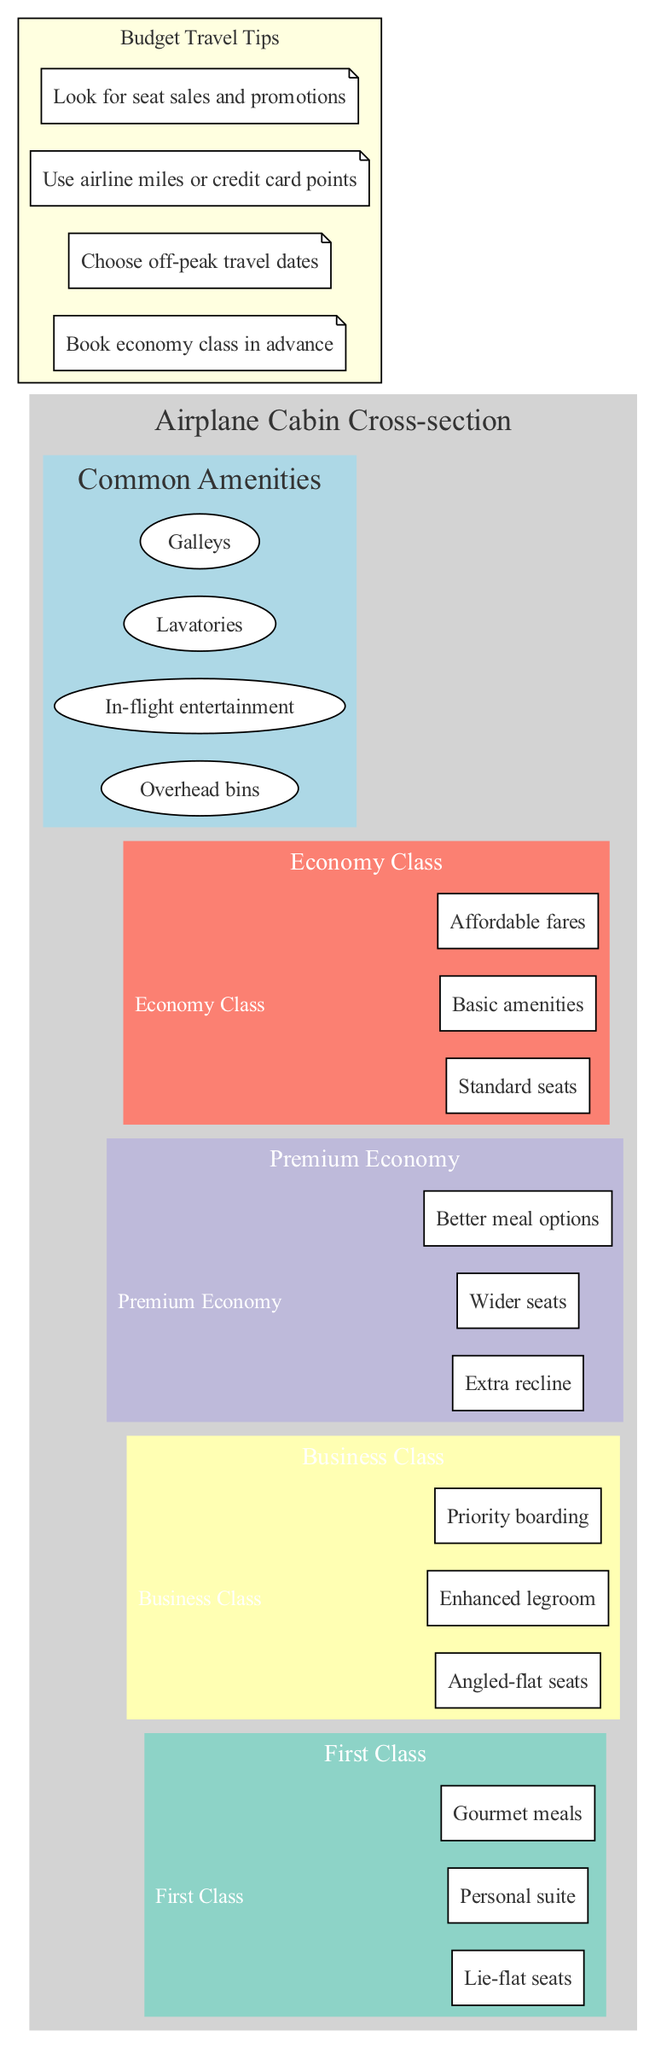What are the three main seating classes shown in the diagram? The diagram highlights four seating classes: First Class, Business Class, Premium Economy, and Economy Class. The question asks for three of these classes, which can be any three listed in the diagram. Common selections based on comfort and amenities would be First Class, Business Class, and Premium Economy.
Answer: First Class, Business Class, Premium Economy What is a feature unique to First Class? Under First Class in the diagram, one feature listed is "Personal suite." This feature distinctly represents the high level of comfort and privacy offered to First Class passengers compared to other classes.
Answer: Personal suite What type of seats are found in Business Class? The diagram specifies that Business Class has "Angled-flat seats." This detail distinguishes the type of seating provided in this class compared to others like Economy.
Answer: Angled-flat seats How many common amenities are listed in the diagram? The diagram provides a list of four common amenities, which include Overhead bins, In-flight entertainment, Lavatories, and Galleys. By counting these features, we ascertain the total number.
Answer: 4 Which seating class offers the most comfortable seating option? In the diagram, First Class is noted for having "Lie-flat seats," which offers the highest comfort level among the seating classes, making it the most luxurious option available.
Answer: Lie-flat seats How does the Economy Class prioritize its offerings? Economy Class is characterized in the diagram with "Standard seats," "Basic amenities," and "Affordable fares," emphasizing cost-effectiveness while sacrificing some comfort and features found in higher classes.
Answer: Affordable fares What is one tip for budget travel mentioned in the diagram? The diagram lists several tips for budget travel, and one of them is "Choose off-peak travel dates." This advice helps travelers find cheaper fares by avoiding busy travel periods.
Answer: Choose off-peak travel dates Which class allows for priority boarding? The diagram states that Business Class passengers receive "Priority boarding." This feature highlights the benefits of flying in this class compared to others like Economy.
Answer: Priority boarding What is the additional meal improvement found in Premium Economy compared to Economy Class? The diagram details that Premium Economy offers "Better meal options," representing an upgrade in food quality compared to the basic offerings in Economy Class.
Answer: Better meal options What is a common amenity available to all classes comprising the cabin? The diagram includes several common amenities, one of which is "In-flight entertainment." This service is accessible to passengers across all seating classes, enhancing the overall flying experience.
Answer: In-flight entertainment 